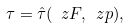<formula> <loc_0><loc_0><loc_500><loc_500>\tau = \hat { \tau } ( \ z F , \ z p ) ,</formula> 